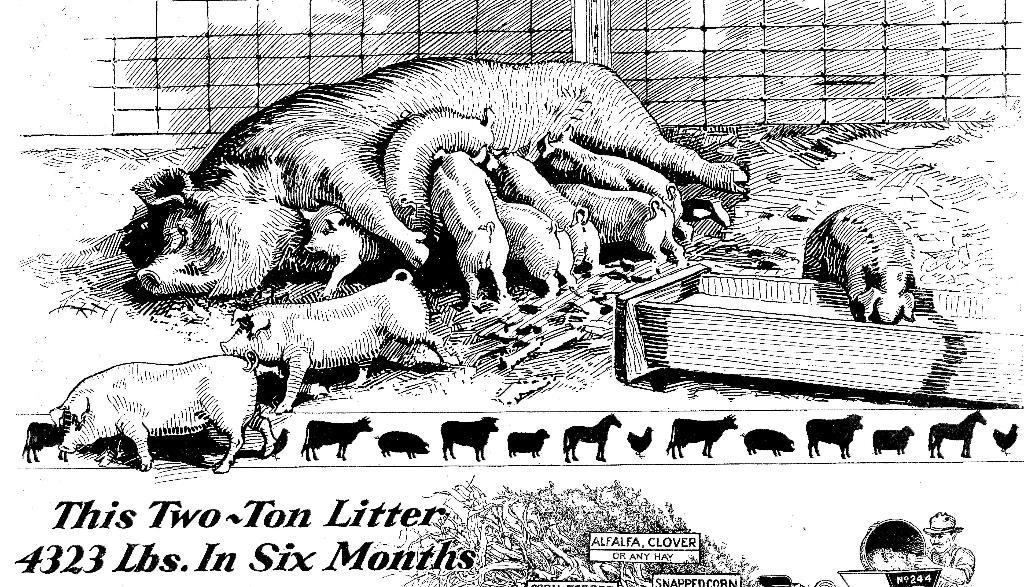What is present in the image that contains visual information? There is a poster in the image. What types of subjects are depicted on the poster? The poster contains images of animals and a person. Is there any text on the poster? Yes, there is text on the poster. What type of can is shown in the image? There is no can present in the image; it only features a poster with images of animals, a person, and text. 